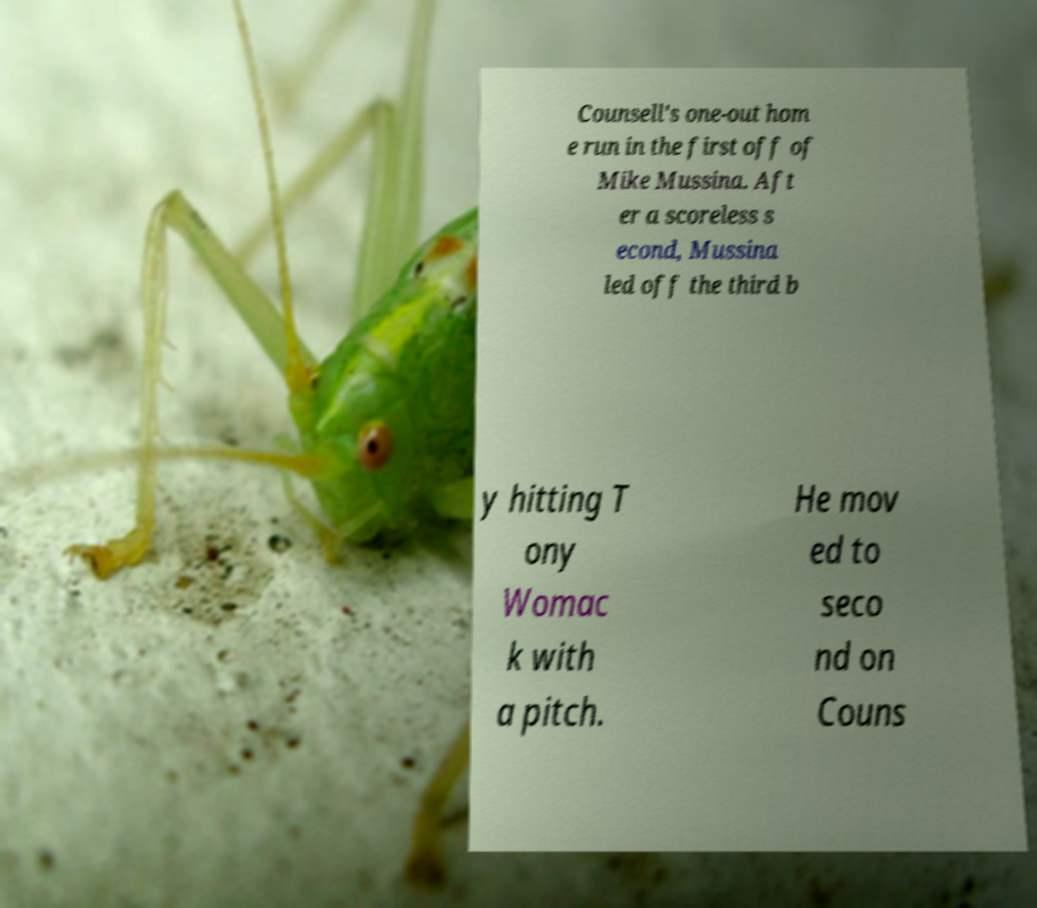Please read and relay the text visible in this image. What does it say? Counsell's one-out hom e run in the first off of Mike Mussina. Aft er a scoreless s econd, Mussina led off the third b y hitting T ony Womac k with a pitch. He mov ed to seco nd on Couns 